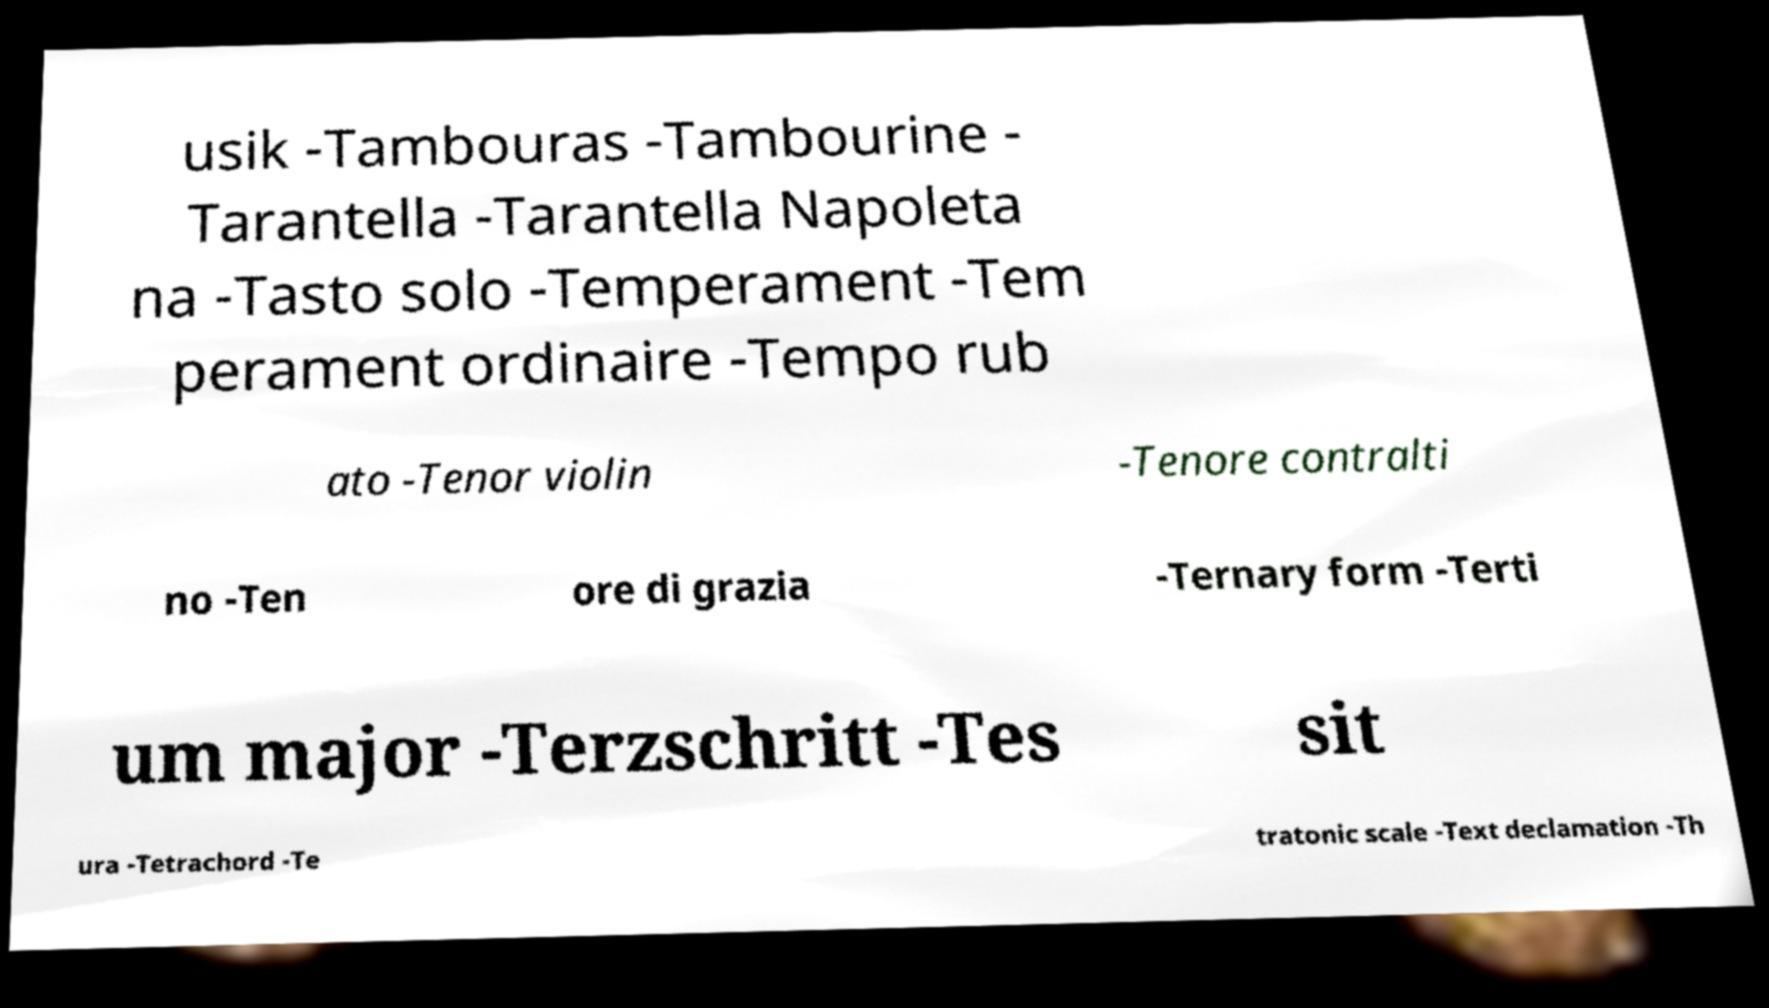Could you extract and type out the text from this image? usik -Tambouras -Tambourine - Tarantella -Tarantella Napoleta na -Tasto solo -Temperament -Tem perament ordinaire -Tempo rub ato -Tenor violin -Tenore contralti no -Ten ore di grazia -Ternary form -Terti um major -Terzschritt -Tes sit ura -Tetrachord -Te tratonic scale -Text declamation -Th 